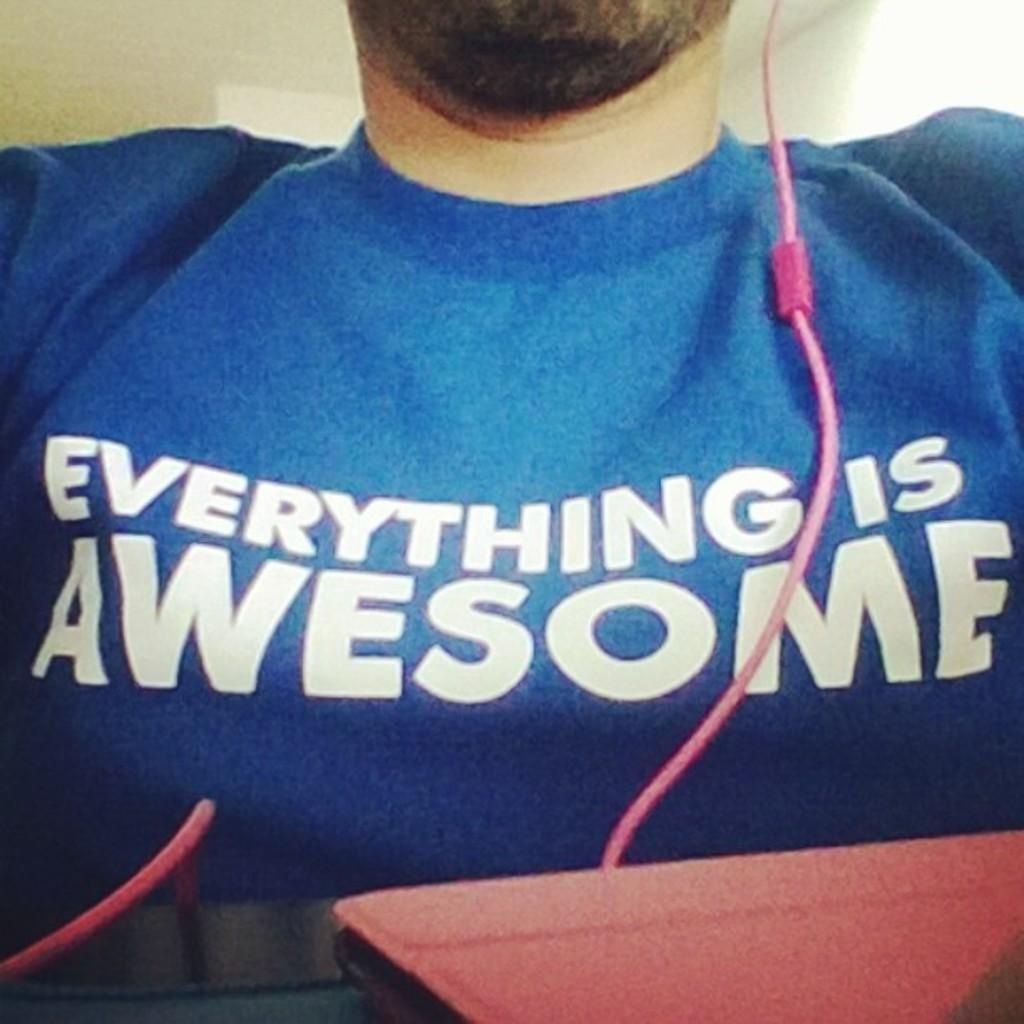<image>
Provide a brief description of the given image. the front of a blue tshirt that says everything is awesome 